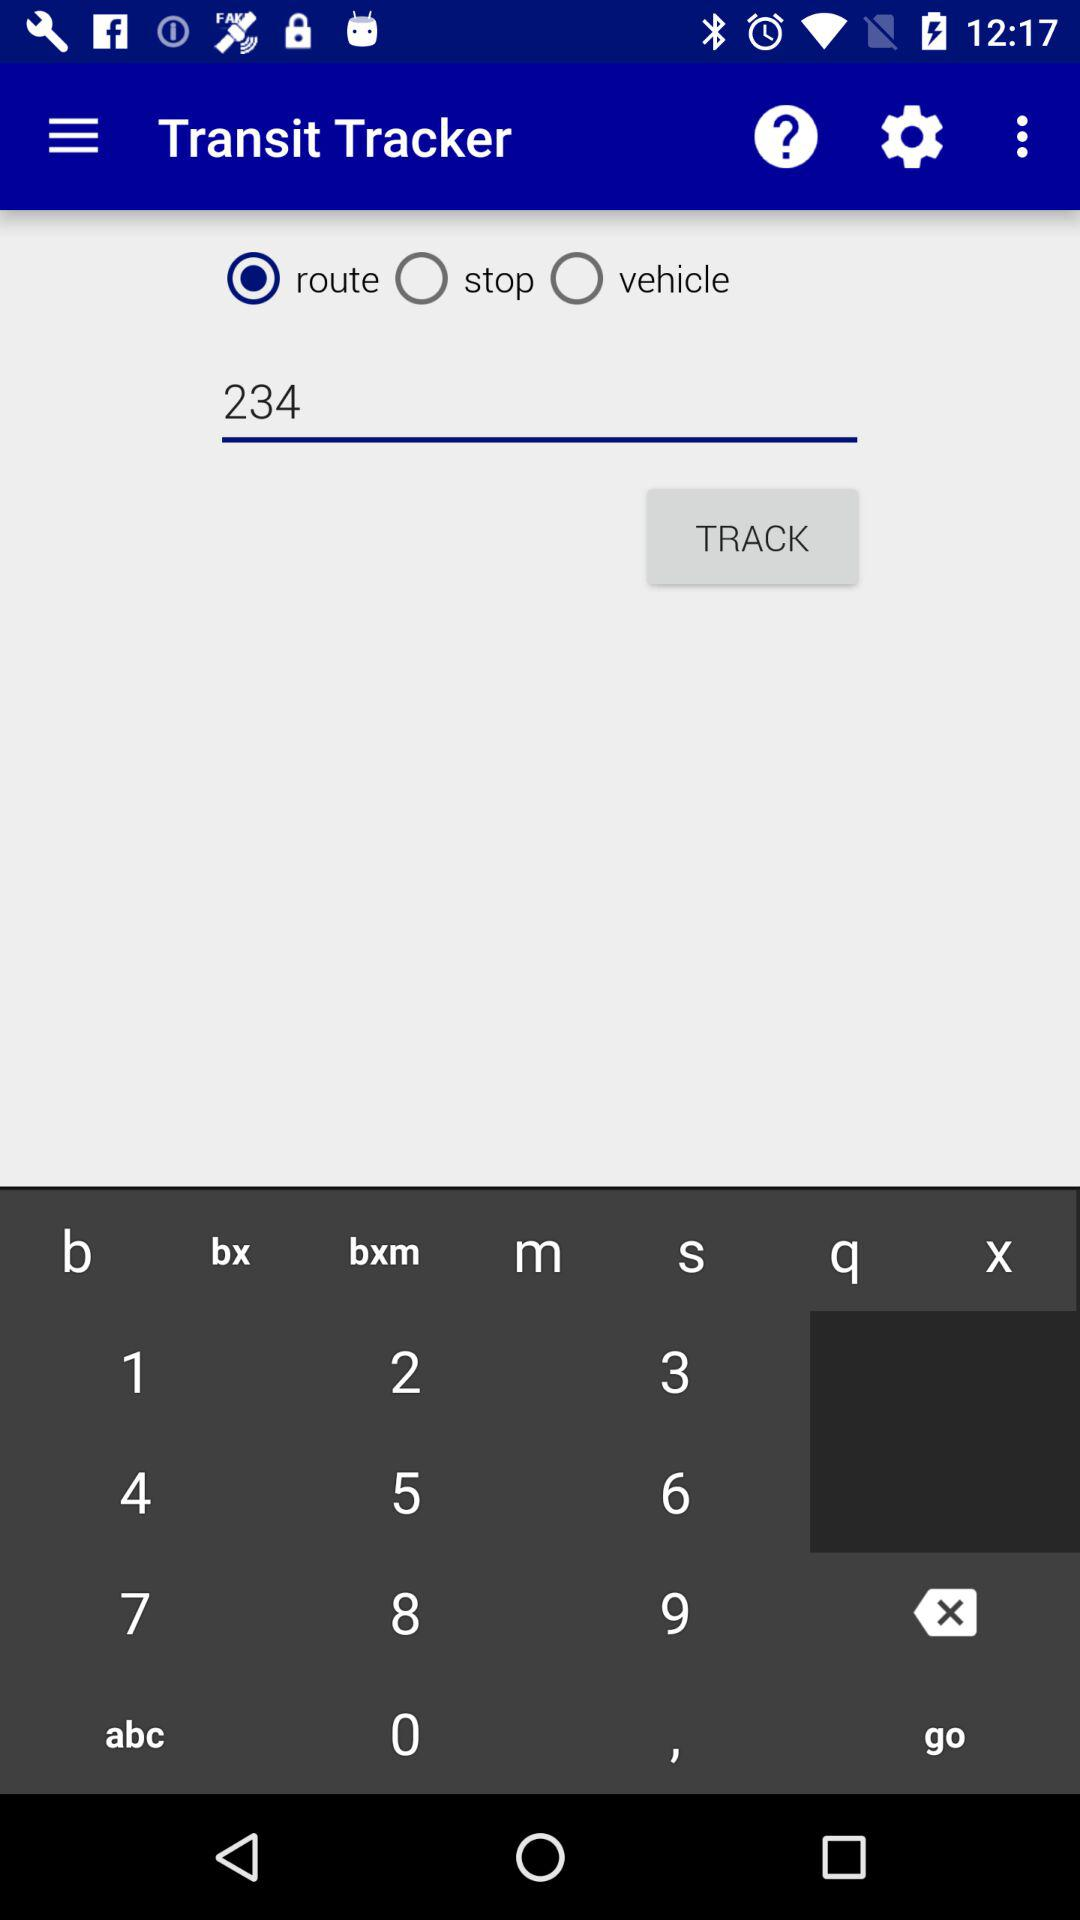What is the application name? The application name is "Transit Tracker". 